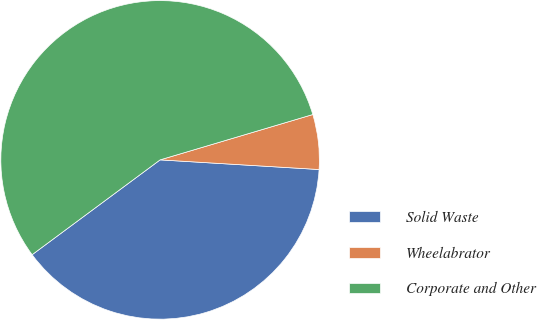Convert chart. <chart><loc_0><loc_0><loc_500><loc_500><pie_chart><fcel>Solid Waste<fcel>Wheelabrator<fcel>Corporate and Other<nl><fcel>38.89%<fcel>5.56%<fcel>55.56%<nl></chart> 